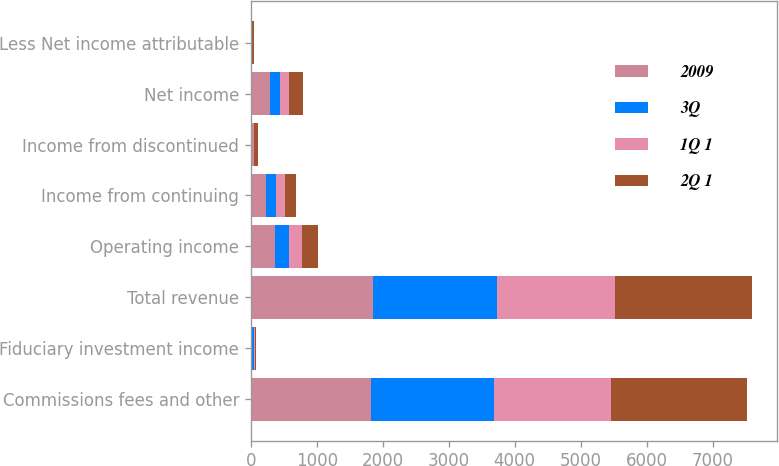<chart> <loc_0><loc_0><loc_500><loc_500><stacked_bar_chart><ecel><fcel>Commissions fees and other<fcel>Fiduciary investment income<fcel>Total revenue<fcel>Operating income<fcel>Income from continuing<fcel>Income from discontinued<fcel>Net income<fcel>Less Net income attributable<nl><fcel>2009<fcel>1821<fcel>25<fcel>1846<fcel>366<fcel>235<fcel>50<fcel>285<fcel>5<nl><fcel>3Q<fcel>1863<fcel>19<fcel>1882<fcel>220<fcel>153<fcel>2<fcel>155<fcel>6<nl><fcel>1Q 1<fcel>1778<fcel>16<fcel>1794<fcel>194<fcel>131<fcel>3<fcel>134<fcel>14<nl><fcel>2Q 1<fcel>2059<fcel>14<fcel>2073<fcel>241<fcel>162<fcel>56<fcel>218<fcel>20<nl></chart> 